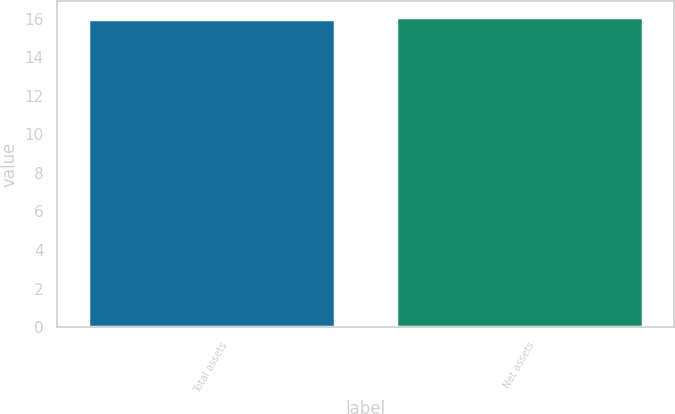Convert chart. <chart><loc_0><loc_0><loc_500><loc_500><bar_chart><fcel>Total assets<fcel>Net assets<nl><fcel>16<fcel>16.1<nl></chart> 